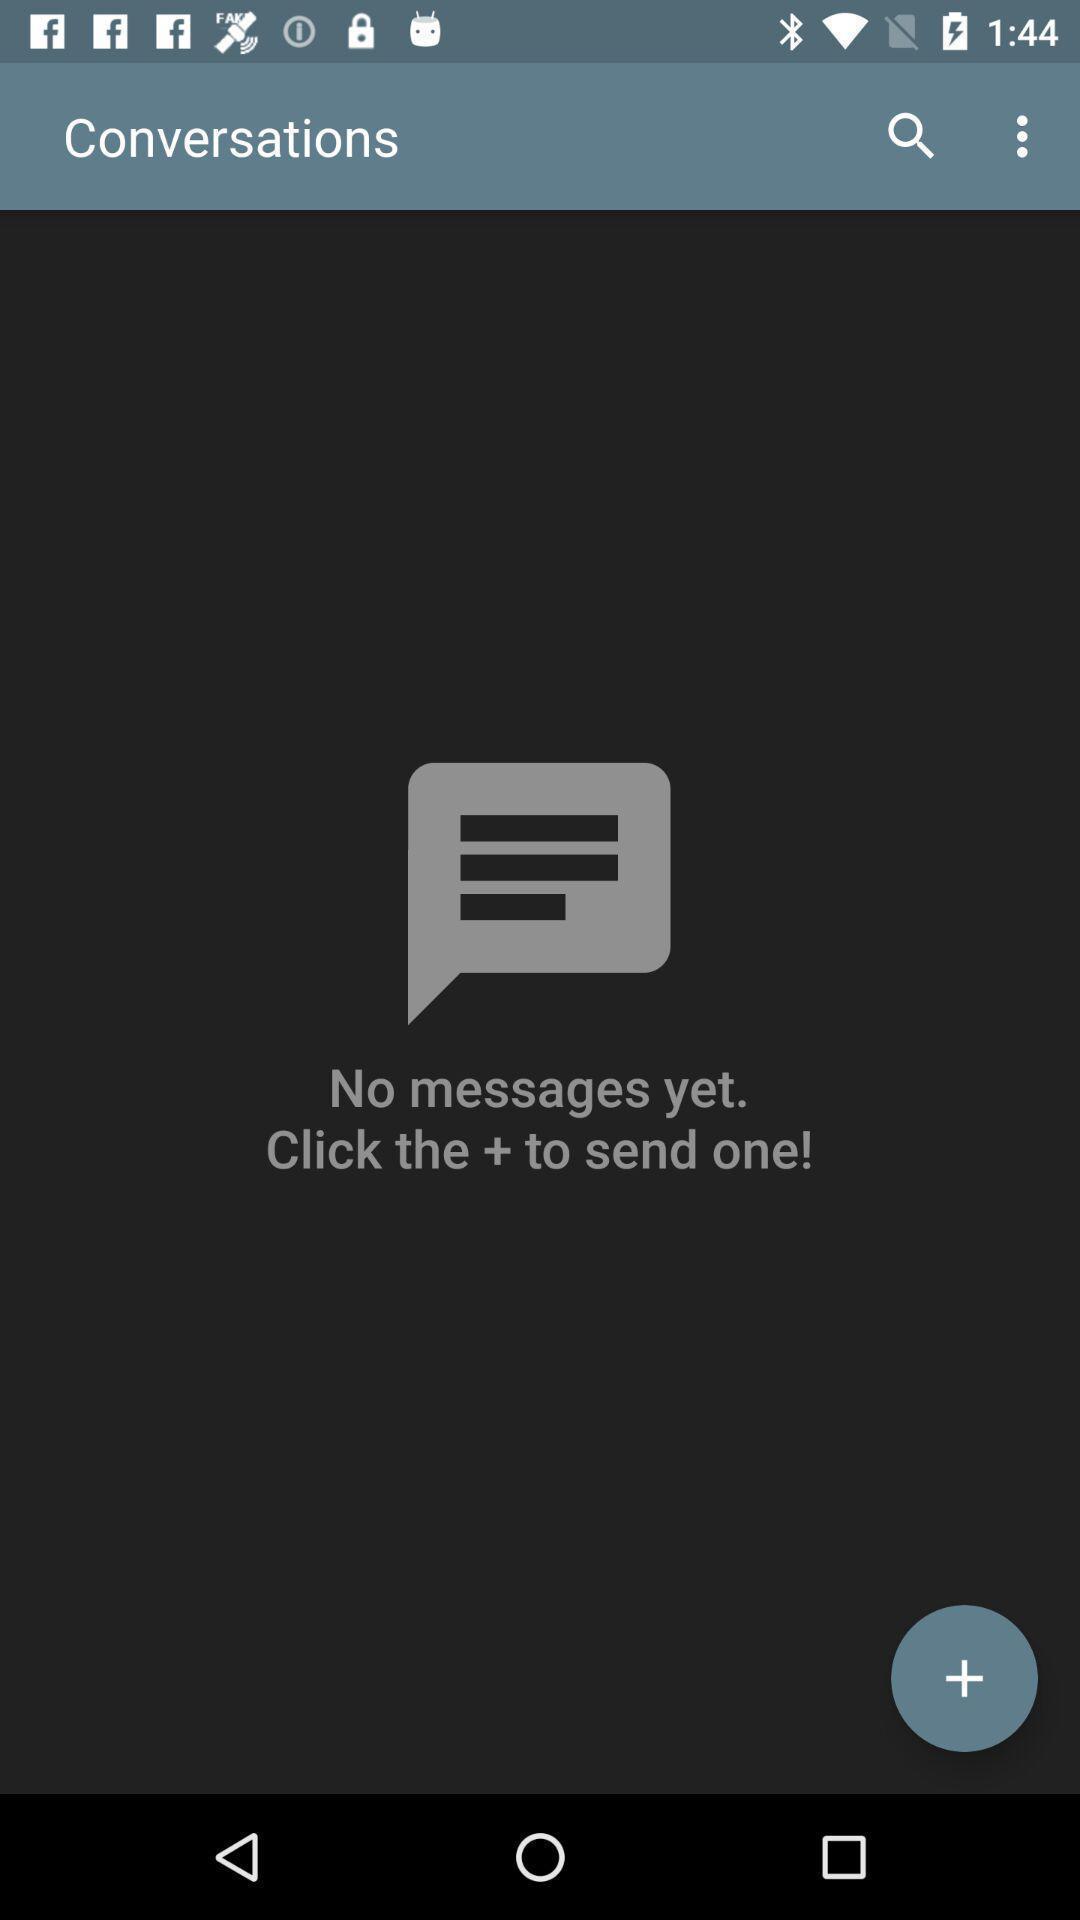Describe the content in this image. Screen showing the chat page. 